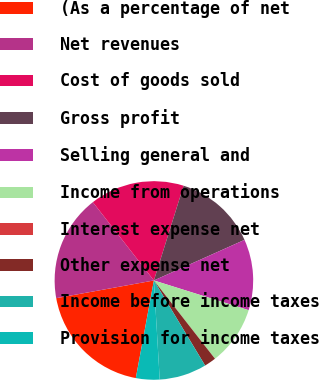<chart> <loc_0><loc_0><loc_500><loc_500><pie_chart><fcel>(As a percentage of net<fcel>Net revenues<fcel>Cost of goods sold<fcel>Gross profit<fcel>Selling general and<fcel>Income from operations<fcel>Interest expense net<fcel>Other expense net<fcel>Income before income taxes<fcel>Provision for income taxes<nl><fcel>19.23%<fcel>17.31%<fcel>15.38%<fcel>13.46%<fcel>11.54%<fcel>9.62%<fcel>0.0%<fcel>1.92%<fcel>7.69%<fcel>3.85%<nl></chart> 